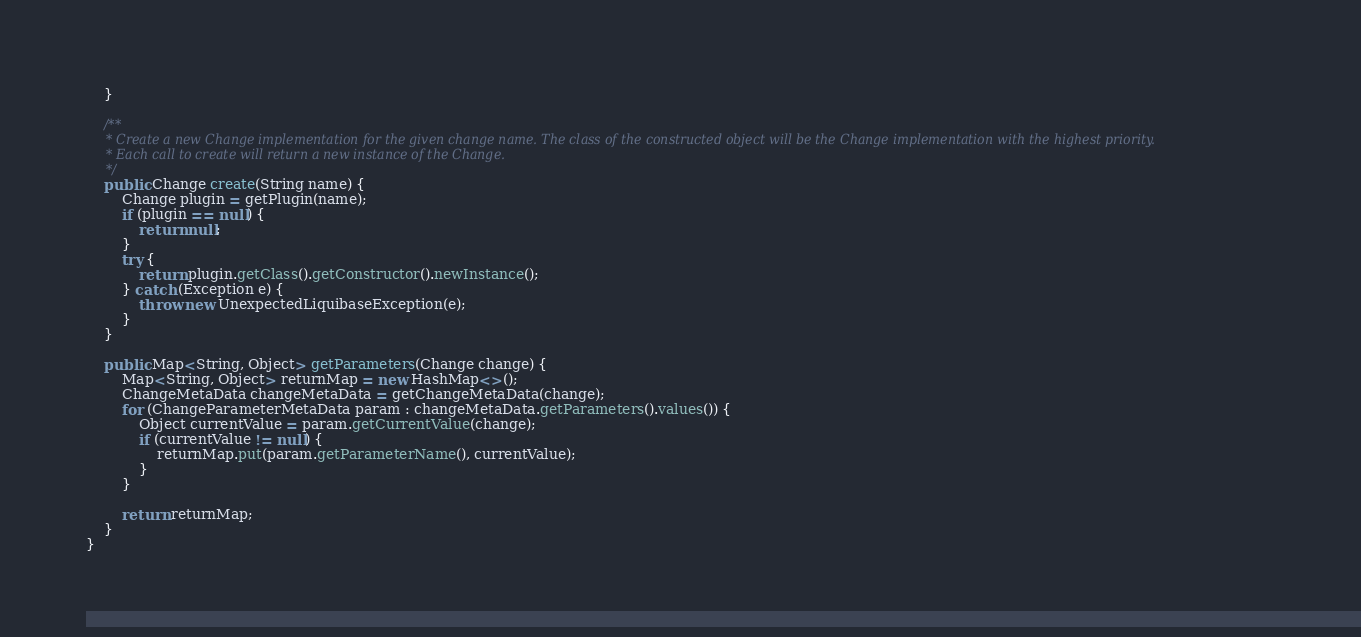<code> <loc_0><loc_0><loc_500><loc_500><_Java_>    }

    /**
     * Create a new Change implementation for the given change name. The class of the constructed object will be the Change implementation with the highest priority.
     * Each call to create will return a new instance of the Change.
     */
    public Change create(String name) {
        Change plugin = getPlugin(name);
        if (plugin == null) {
            return null;
        }
        try {
            return plugin.getClass().getConstructor().newInstance();
        } catch (Exception e) {
            throw new UnexpectedLiquibaseException(e);
        }
    }

    public Map<String, Object> getParameters(Change change) {
        Map<String, Object> returnMap = new HashMap<>();
        ChangeMetaData changeMetaData = getChangeMetaData(change);
        for (ChangeParameterMetaData param : changeMetaData.getParameters().values()) {
            Object currentValue = param.getCurrentValue(change);
            if (currentValue != null) {
                returnMap.put(param.getParameterName(), currentValue);
            }
        }

        return returnMap;
    }
}
</code> 